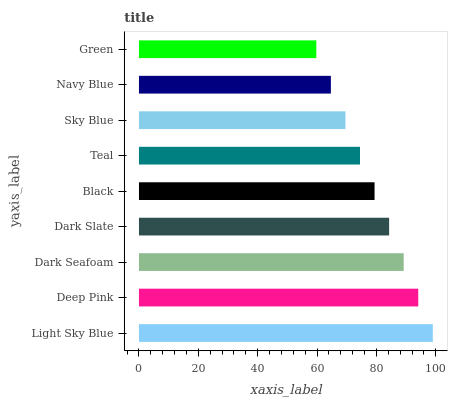Is Green the minimum?
Answer yes or no. Yes. Is Light Sky Blue the maximum?
Answer yes or no. Yes. Is Deep Pink the minimum?
Answer yes or no. No. Is Deep Pink the maximum?
Answer yes or no. No. Is Light Sky Blue greater than Deep Pink?
Answer yes or no. Yes. Is Deep Pink less than Light Sky Blue?
Answer yes or no. Yes. Is Deep Pink greater than Light Sky Blue?
Answer yes or no. No. Is Light Sky Blue less than Deep Pink?
Answer yes or no. No. Is Black the high median?
Answer yes or no. Yes. Is Black the low median?
Answer yes or no. Yes. Is Navy Blue the high median?
Answer yes or no. No. Is Sky Blue the low median?
Answer yes or no. No. 